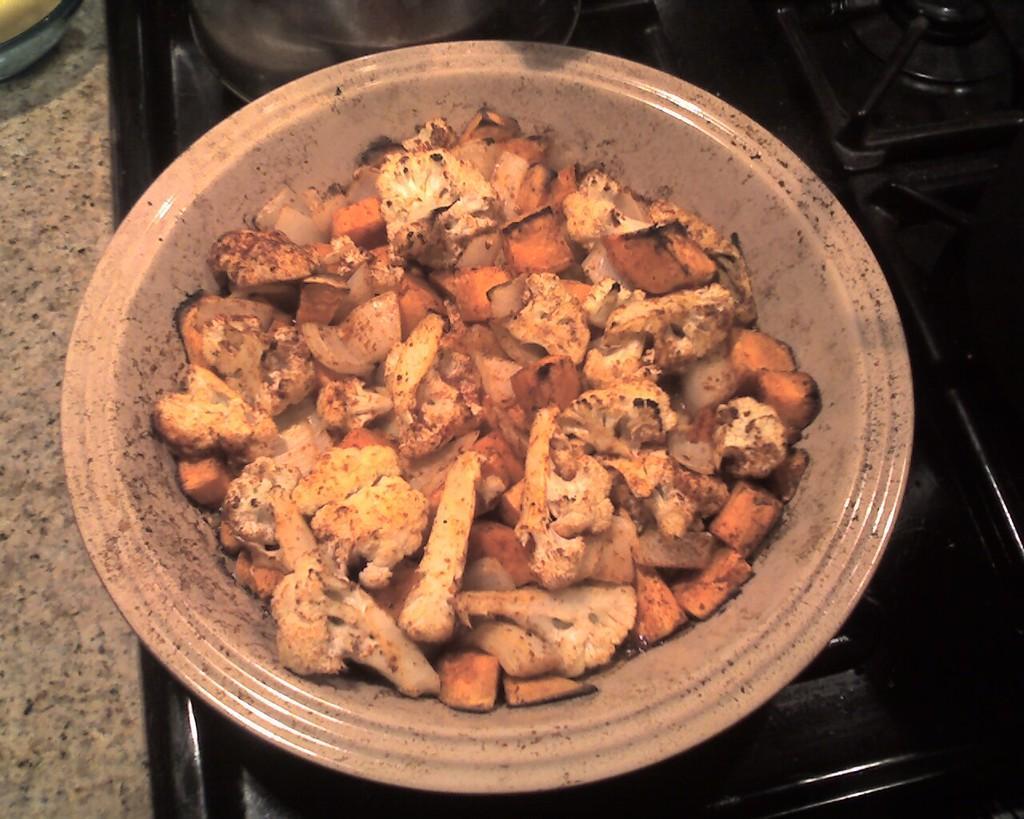In one or two sentences, can you explain what this image depicts? In this image I can see a bowl with some food items on a stove. 